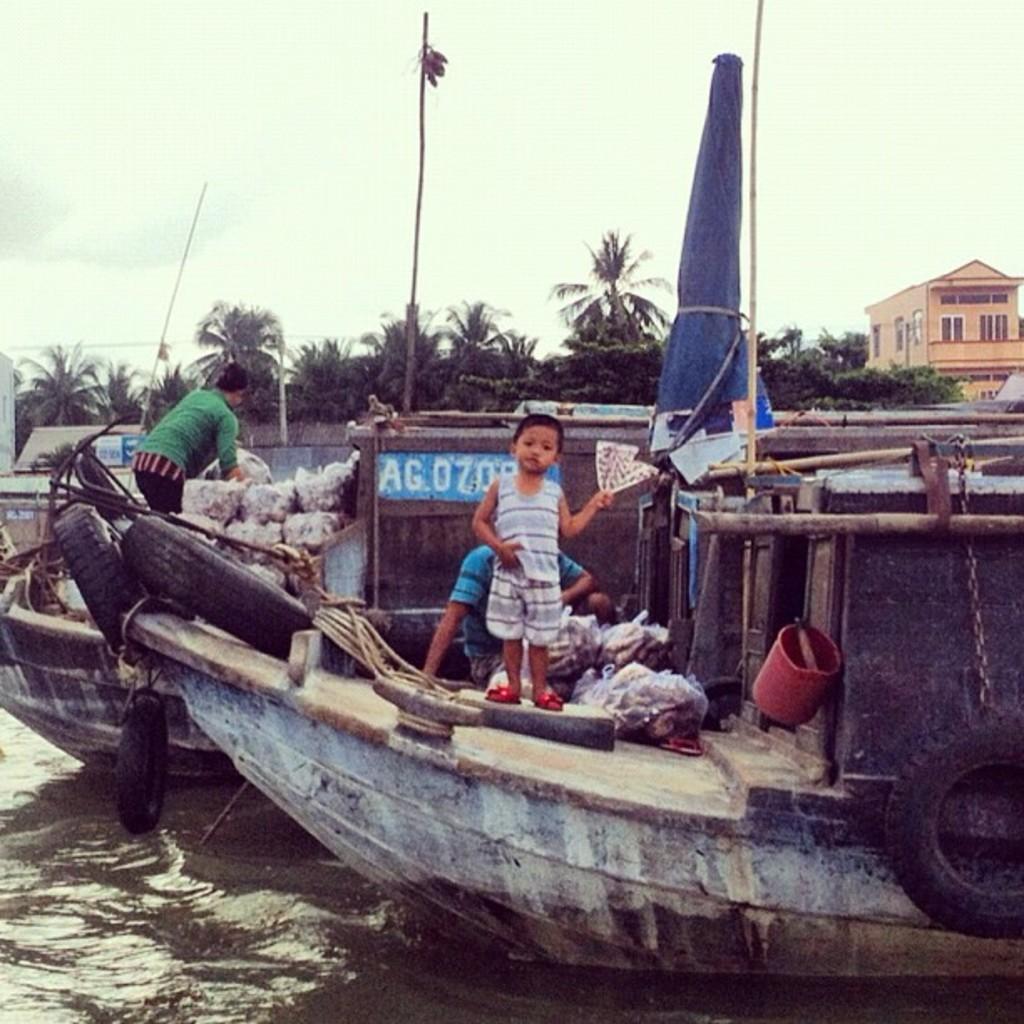In one or two sentences, can you explain what this image depicts? In this image we can see boats. On the boats there are few people. Also there are tires, packets and many other things. In the background there are trees. On the right side there is a building with windows. And also there is sky. 